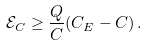<formula> <loc_0><loc_0><loc_500><loc_500>\mathcal { E } _ { C } \geq \frac { Q } { C } ( C _ { E } - C ) \, .</formula> 